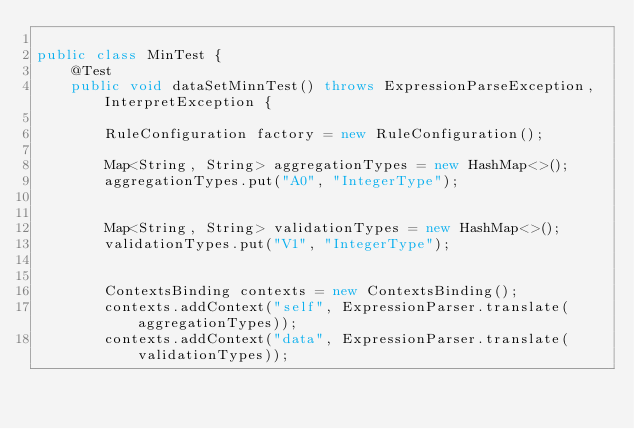Convert code to text. <code><loc_0><loc_0><loc_500><loc_500><_Java_>
public class MinTest {
    @Test
    public void dataSetMinnTest() throws ExpressionParseException, InterpretException {

        RuleConfiguration factory = new RuleConfiguration();

        Map<String, String> aggregationTypes = new HashMap<>();
        aggregationTypes.put("A0", "IntegerType");


        Map<String, String> validationTypes = new HashMap<>();
        validationTypes.put("V1", "IntegerType");


        ContextsBinding contexts = new ContextsBinding();
        contexts.addContext("self", ExpressionParser.translate(aggregationTypes));
        contexts.addContext("data", ExpressionParser.translate(validationTypes));

</code> 